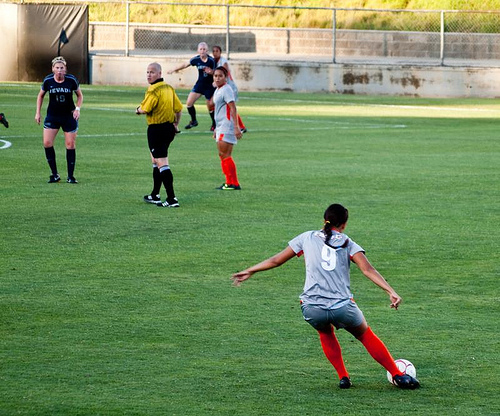<image>
Is the player on the ball? No. The player is not positioned on the ball. They may be near each other, but the player is not supported by or resting on top of the ball. 